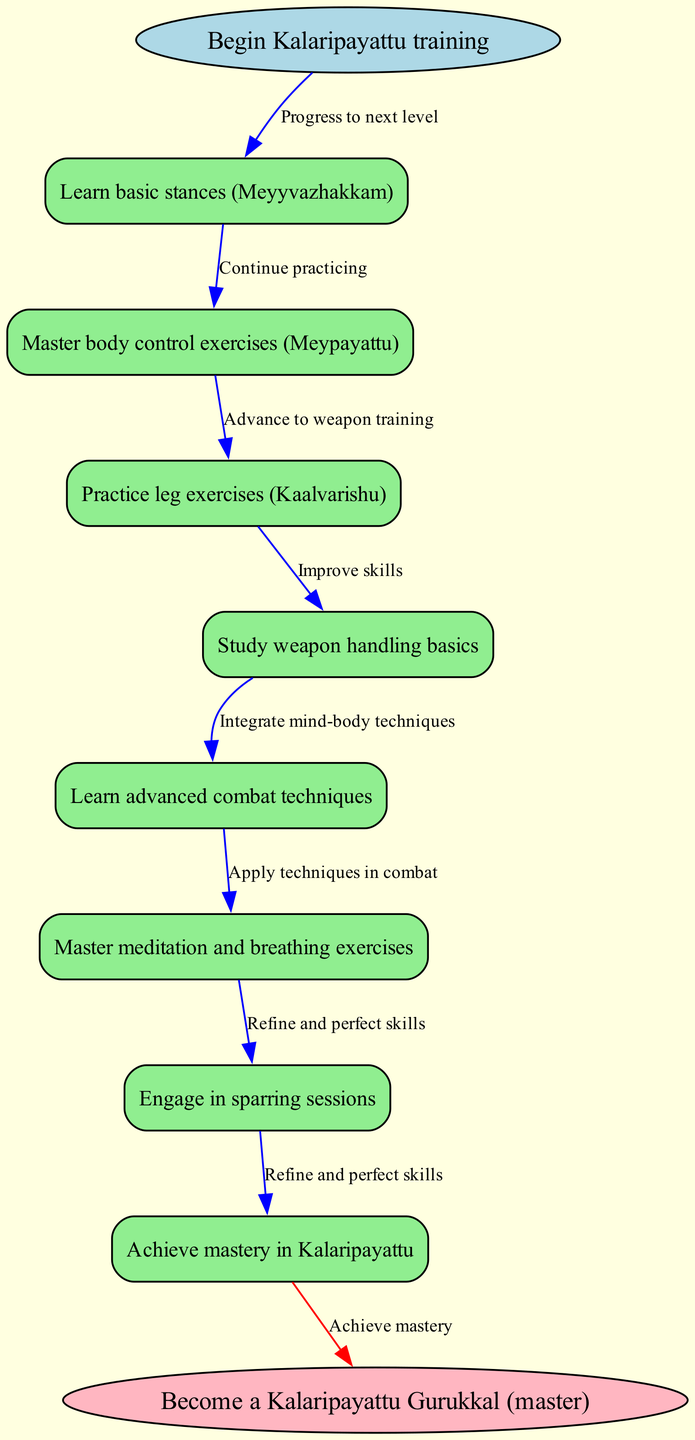What is the first step in Kalaripayattu training? The first step listed in the diagram is "Learn basic stances (Meyyvazhakkam)", which is directly connected to the start node.
Answer: Learn basic stances (Meyyvazhakkam) How many nodes are there in total on the diagram? The diagram includes one start node, eight training steps, and one end node, totaling ten nodes.
Answer: Ten What is the last node before becoming a master? The last node before reaching the end, which signifies mastery, is "Achieve mastery in Kalaripayattu", as it connects directly to the end node.
Answer: Achieve mastery in Kalaripayattu What type of exercises are learned after practicing leg exercises? The node that follows "Practice leg exercises (Kaalvarishu)" is "Study weapon handling basics", indicating the next area of focus in training.
Answer: Study weapon handling basics What edge connects the start node to the first training step? The edge connecting the start node to "Learn basic stances (Meyyvazhakkam)" is labeled "Progress to next level", indicating the action to take.
Answer: Progress to next level After mastering body control exercises, what is the next focus? Following "Master body control exercises (Meypayattu)", the next focus is "Practice leg exercises (Kaalvarishu)", as shown in the flow of the diagram.
Answer: Practice leg exercises (Kaalvarishu) How many edges are connected to the last training step? The last training step, "Engage in sparring sessions", has one outgoing edge labeled "Refine and perfect skills" that leads to the end. Therefore, it connects to one edge.
Answer: One What is the primary focus of the first node in the training regimen? The primary focus of the first node, "Learn basic stances (Meyyvazhakkam)", is foundational training in stances essential for Kalaripayattu.
Answer: Foundational training in stances What is the relationship between leg exercises and weapon handling? "Practice leg exercises (Kaalvarishu)" leads directly to "Study weapon handling basics", establishing a sequential training approach where leg exercises precede weapon training.
Answer: Sequential training approach How is mastery attained in Kalaripayattu according to the diagram? Mastery is attained through a series of steps culminating in the last node "Achieve mastery in Kalaripayattu", which connects to the end node, indicating the completion of the training regimen.
Answer: Achieve mastery in Kalaripayattu 